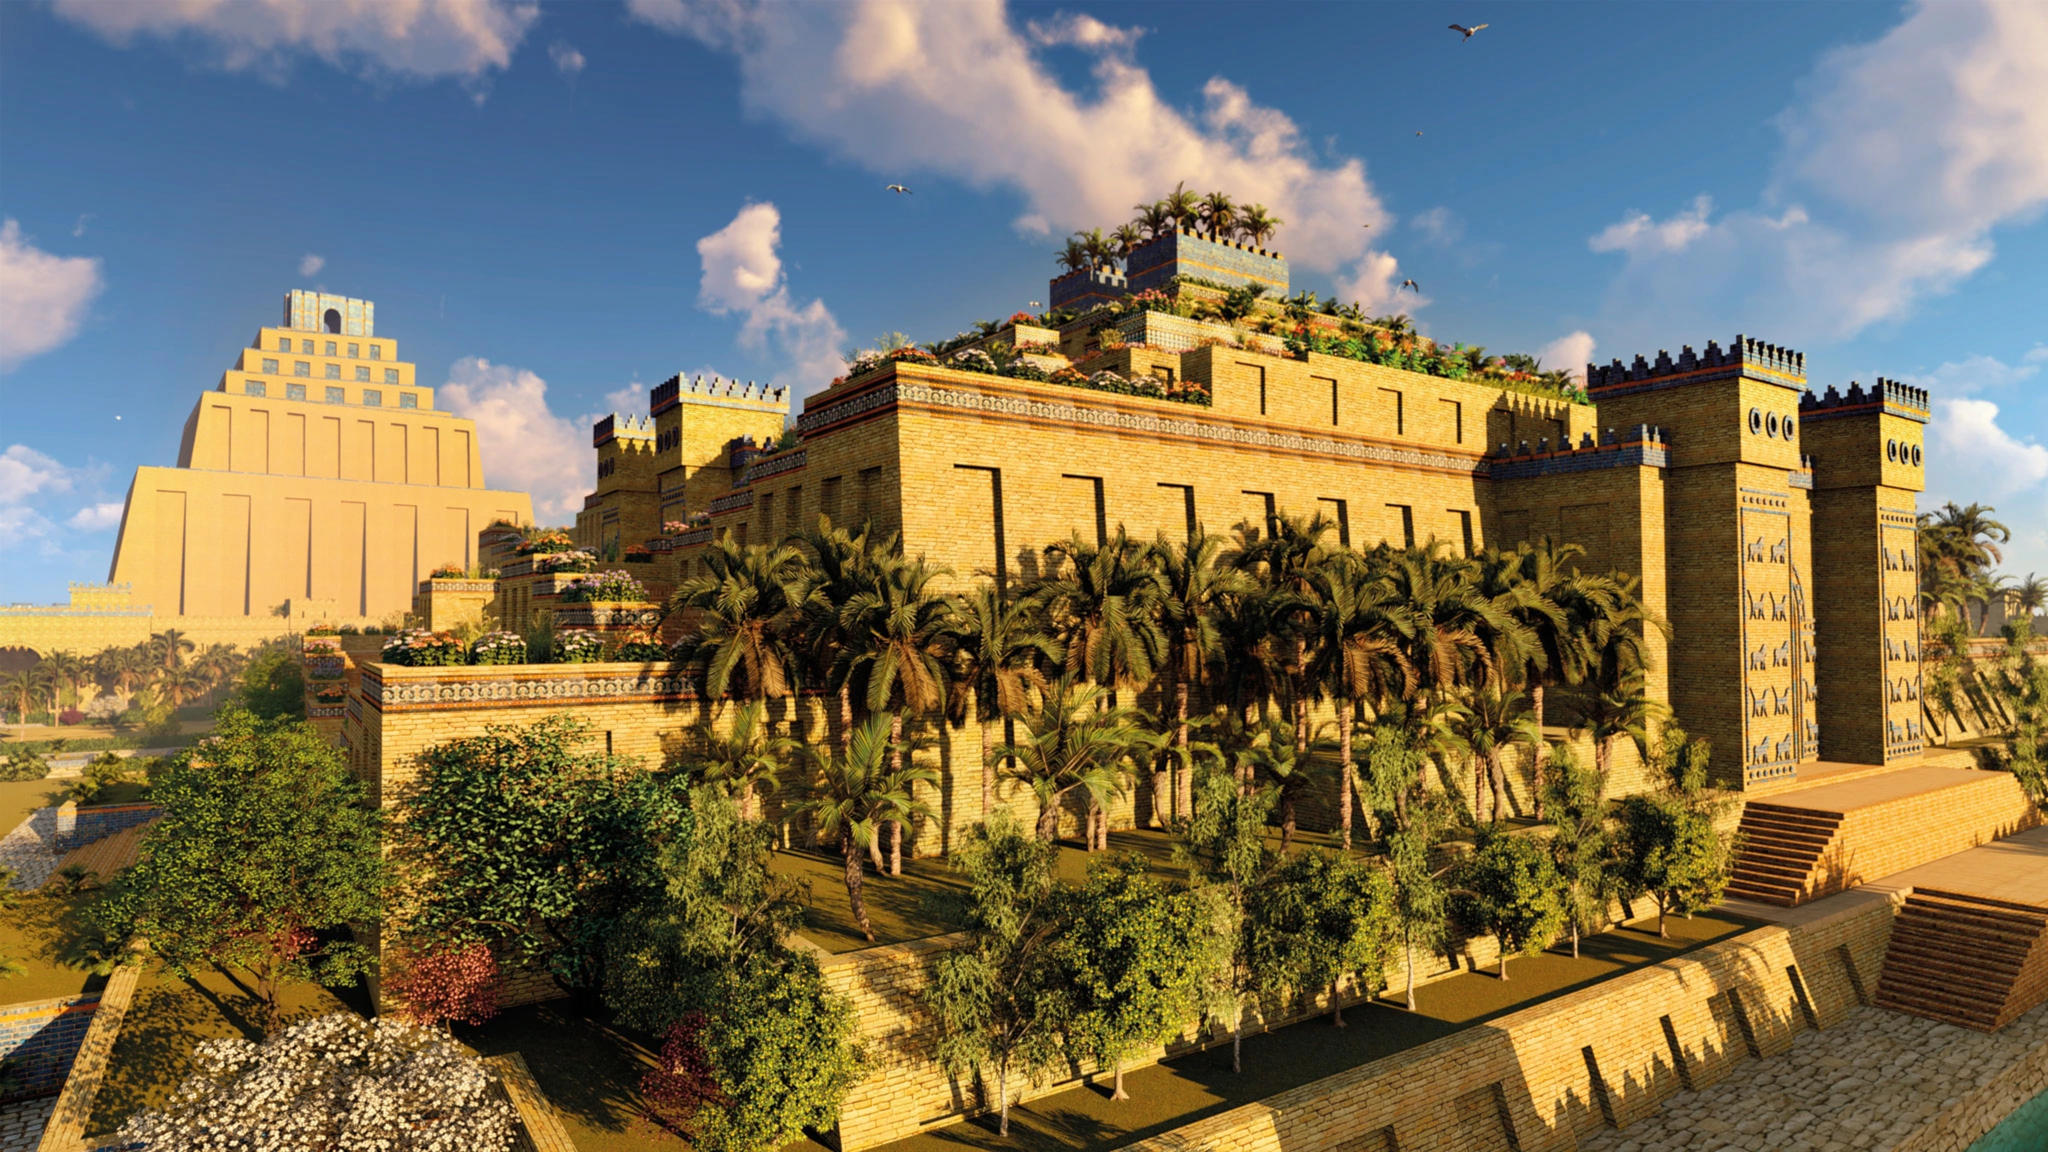If the image were a scene from a movie, what would the plot be? If the image were a scene from a movie, the plot would revolve around the grandeur and mystery of ancient Babylon. The story might center on a young archaeologist who discovers a hidden chamber beneath the Hanging Gardens. Within, they find ancient scrolls that tell of a lost Babylonian prince who disappeared under mysterious circumstances. As the archaeologist deciphers the scrolls, they unearth clues that lead them on an epic adventure through the city's stunning architecture, uncovering secret passages and long-forgotten rituals. The plot would weave together historical fact and magical realism, as the archaeologist uncovers a powerful artifact that could alter the course of history. Along the way, they would face treacherous obstacles and uncover truths about Babylon’s lost legacy, all while being pursued by a shadowy figure determined to keep the city's secrets buried. Describe a day in the life of a Babylonian noble living in one of these grand towers. A day in the life of a Babylonian noble living in one of these grand towers would begin with the sunrise casting a warm glow over the city. The noble would wake to the sound of birds and the sight of verdant gardens from their high vantage point. They would start their day with a bath in a luxurious chamber, followed by a breakfast of bread, fruit, and exotic delicacies. Throughout the morning, the noble would attend to administrative tasks, perhaps meeting with city officials or overseeing the management of their estates. At midday, they might enjoy a leisurely stroll through the opulent gardens, engaging in philosophical discussions with guests or indulging in various entertainments. The afternoon could be spent observing or participating in religious ceremonies within the ziggurats. As the day concludes, the noble would dine on a sumptuous feast, sharing stories and laughter with family and friends. The evening might feature performances by musicians and dancers, with the noble finally retiring to their private quarters, gazing out at the starlit city before drifting to sleep. 